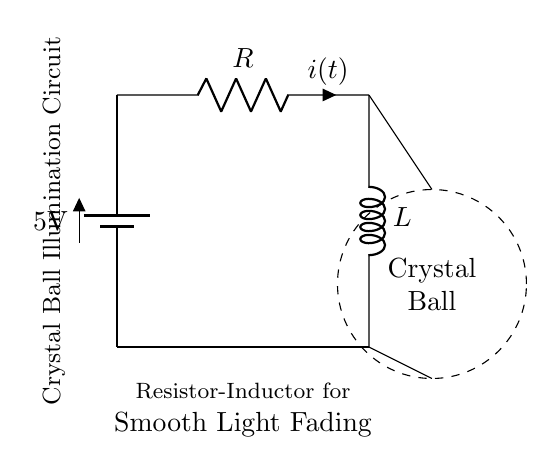What is the voltage of the battery? The circuit diagram shows a battery labeled with a potential difference of 5V. This indicates the voltage provided to the circuit.
Answer: 5V What type of components are present in this circuit? The circuit features a battery, a resistor, and an inductor. These are the primary components designed to create the crystal ball illumination effect.
Answer: Battery, resistor, inductor What is the role of the resistor in this circuit? The resistor in the circuit limits the current flow, which helps in controlling the brightness of the light illuminating the crystal ball. This enables smooth light fading.
Answer: Current limiting What happens to the current when the circuit is first powered on? When the circuit is initially powered on, the current rises gradually as it charges the inductor, creating a smooth fade-in effect for the illumination. This is due to the properties of the inductor opposing sudden changes in current.
Answer: Gradual increase What is the purpose of the inductor in the circuit? The inductor stores energy in a magnetic field and releases it gradually, allowing for a smooth fading effect in the illumination of the crystal ball. This is crucial for preventing any abrupt changes in brightness.
Answer: Smooth fading What is the significance of the dashed circle in the diagram? The dashed circle represents the crystal ball that is being illuminated by the circuit. It highlights the focus of the illumination effect created by the marriage of resistor and inductor.
Answer: Crystal ball How does the resistor-inductor combination affect the light fading? The combination of the resistor and inductor creates an RL circuit that results in an exponential rise and fall in current, leading to a gradual fade-in and fade-out of the light, enhancing the aesthetic appeal.
Answer: Exponential fade 